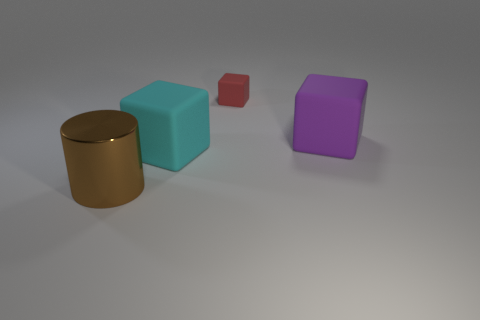Add 1 tiny purple blocks. How many objects exist? 5 Subtract all cylinders. How many objects are left? 3 Subtract 0 gray balls. How many objects are left? 4 Subtract all big objects. Subtract all tiny red matte objects. How many objects are left? 0 Add 4 big brown objects. How many big brown objects are left? 5 Add 2 tiny matte things. How many tiny matte things exist? 3 